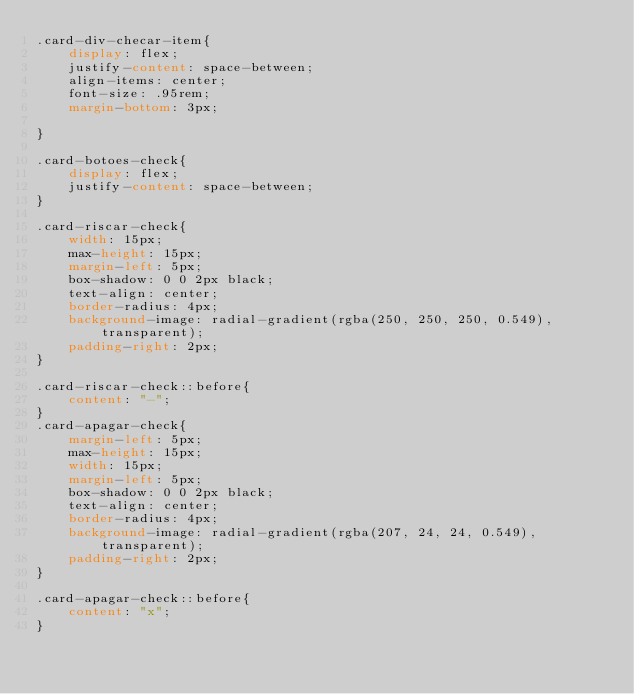<code> <loc_0><loc_0><loc_500><loc_500><_CSS_>.card-div-checar-item{
    display: flex;
    justify-content: space-between;
    align-items: center;
    font-size: .95rem;
    margin-bottom: 3px;

}

.card-botoes-check{
    display: flex;
    justify-content: space-between;
}

.card-riscar-check{
    width: 15px;
    max-height: 15px;
    margin-left: 5px;
    box-shadow: 0 0 2px black;
    text-align: center;
    border-radius: 4px;
    background-image: radial-gradient(rgba(250, 250, 250, 0.549), transparent);
    padding-right: 2px;
}

.card-riscar-check::before{
    content: "-";
}
.card-apagar-check{
    margin-left: 5px;
    max-height: 15px;
    width: 15px;
    margin-left: 5px;
    box-shadow: 0 0 2px black;
    text-align: center;
    border-radius: 4px;
    background-image: radial-gradient(rgba(207, 24, 24, 0.549), transparent);
    padding-right: 2px;
}

.card-apagar-check::before{
    content: "x";
}

</code> 